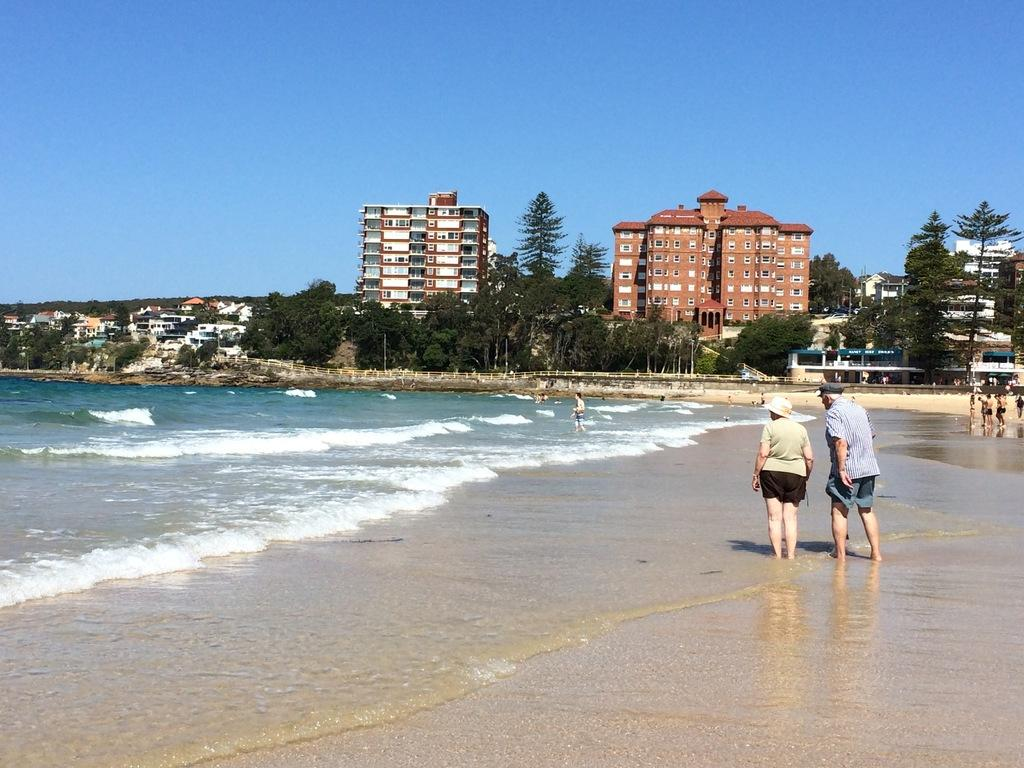What can be seen in the background of the image? The sky is visible in the image. What type of structures are in the image? There are buildings in the image. What type of vegetation is present in the image? Trees are present in the image. Where are the persons located in the image? The persons are standing on the seashore in the image. What type of list can be seen in the image? There is no list present in the image. Can you tell me how many kittens are playing with the oil in the image? There is no oil or kittens present in the image. 